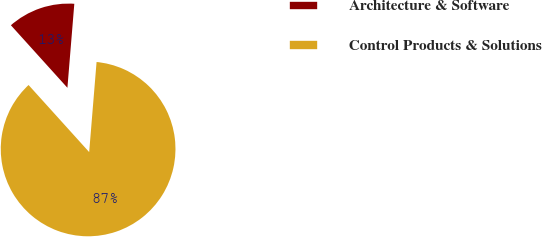Convert chart to OTSL. <chart><loc_0><loc_0><loc_500><loc_500><pie_chart><fcel>Architecture & Software<fcel>Control Products & Solutions<nl><fcel>13.0%<fcel>87.0%<nl></chart> 